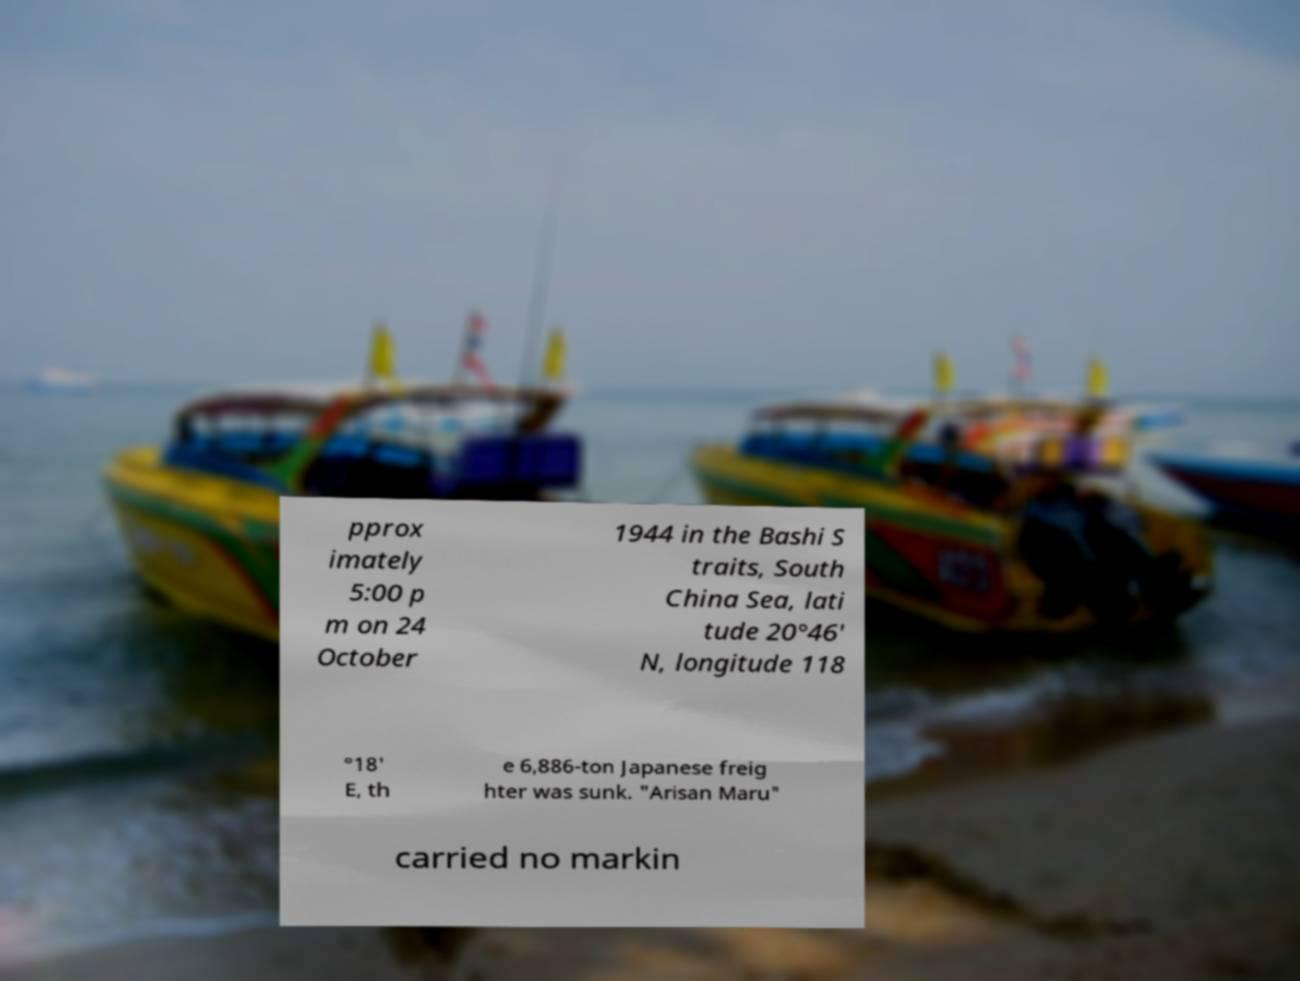What messages or text are displayed in this image? I need them in a readable, typed format. pprox imately 5:00 p m on 24 October 1944 in the Bashi S traits, South China Sea, lati tude 20°46' N, longitude 118 °18' E, th e 6,886-ton Japanese freig hter was sunk. "Arisan Maru" carried no markin 